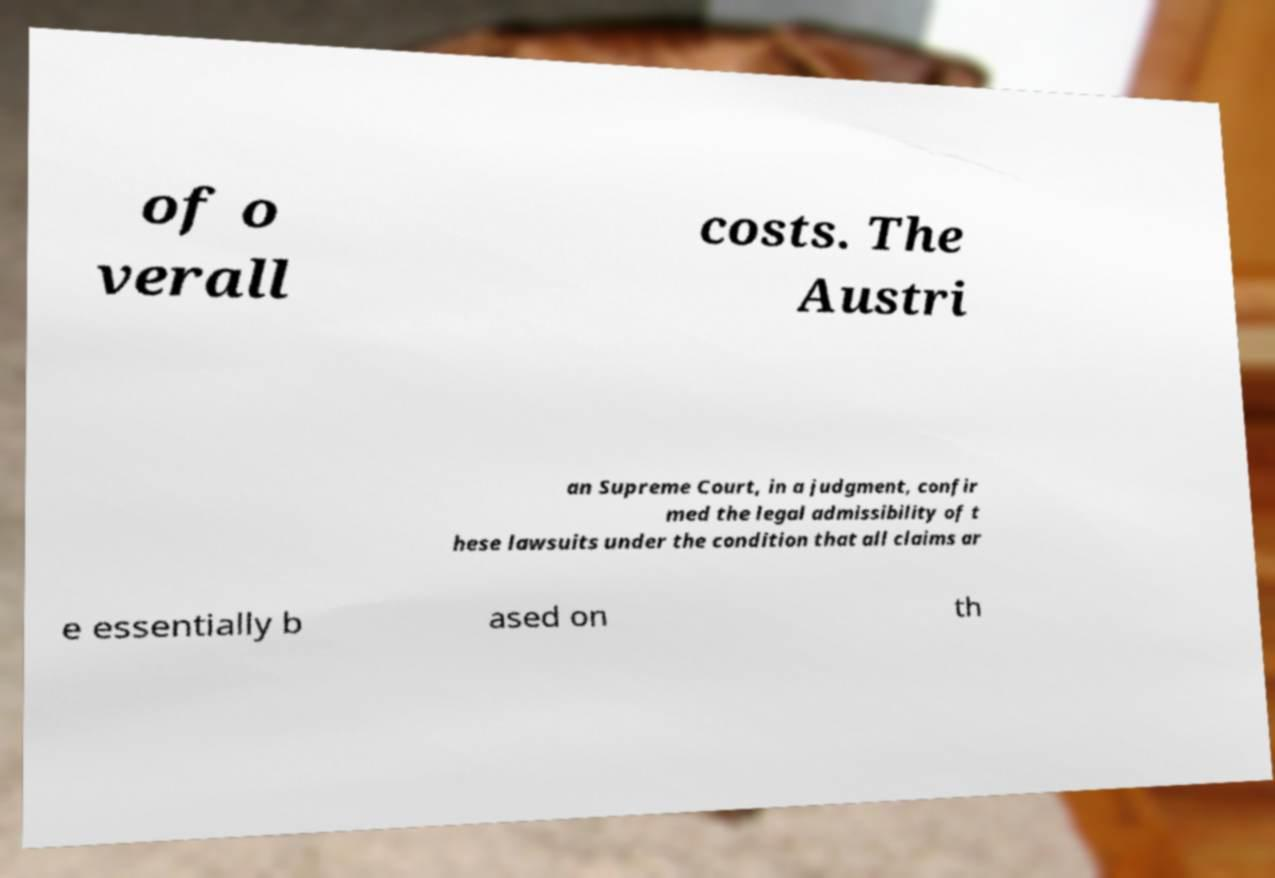I need the written content from this picture converted into text. Can you do that? of o verall costs. The Austri an Supreme Court, in a judgment, confir med the legal admissibility of t hese lawsuits under the condition that all claims ar e essentially b ased on th 